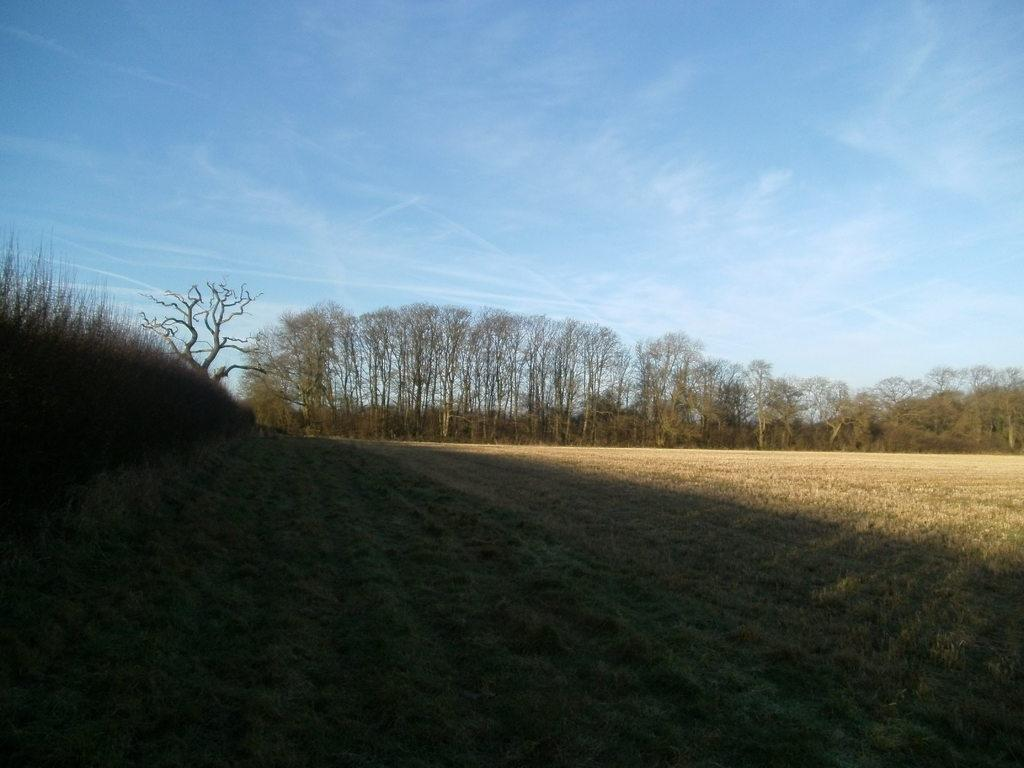What type of surface can be seen in the image? There is ground visible in the image. What is covering the ground in the image? There is grass on the ground. What type of vegetation is present in the image? There are trees in the image. What is visible in the background of the image? The sky is visible in the background of the image. What type of beam is holding up the clouds in the image? There is no beam present in the image, and the clouds are not being held up by any visible structure. 